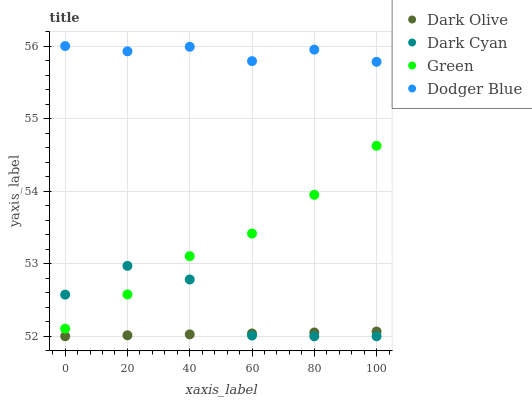Does Dark Olive have the minimum area under the curve?
Answer yes or no. Yes. Does Dodger Blue have the maximum area under the curve?
Answer yes or no. Yes. Does Dodger Blue have the minimum area under the curve?
Answer yes or no. No. Does Dark Olive have the maximum area under the curve?
Answer yes or no. No. Is Dark Olive the smoothest?
Answer yes or no. Yes. Is Dark Cyan the roughest?
Answer yes or no. Yes. Is Dodger Blue the smoothest?
Answer yes or no. No. Is Dodger Blue the roughest?
Answer yes or no. No. Does Dark Cyan have the lowest value?
Answer yes or no. Yes. Does Dodger Blue have the lowest value?
Answer yes or no. No. Does Dodger Blue have the highest value?
Answer yes or no. Yes. Does Dark Olive have the highest value?
Answer yes or no. No. Is Dark Olive less than Dodger Blue?
Answer yes or no. Yes. Is Green greater than Dark Olive?
Answer yes or no. Yes. Does Green intersect Dark Cyan?
Answer yes or no. Yes. Is Green less than Dark Cyan?
Answer yes or no. No. Is Green greater than Dark Cyan?
Answer yes or no. No. Does Dark Olive intersect Dodger Blue?
Answer yes or no. No. 